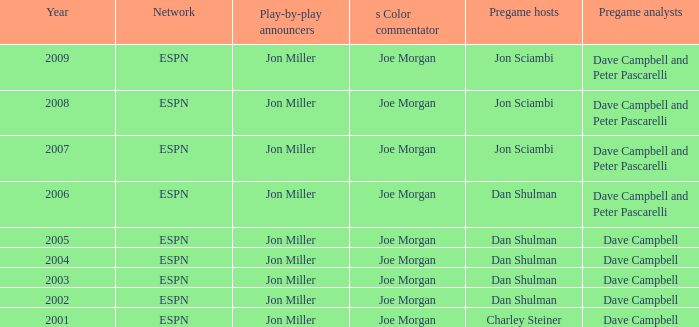Who is the color analyst when the pregame presenter is jon sciambi? Joe Morgan, Joe Morgan, Joe Morgan. 